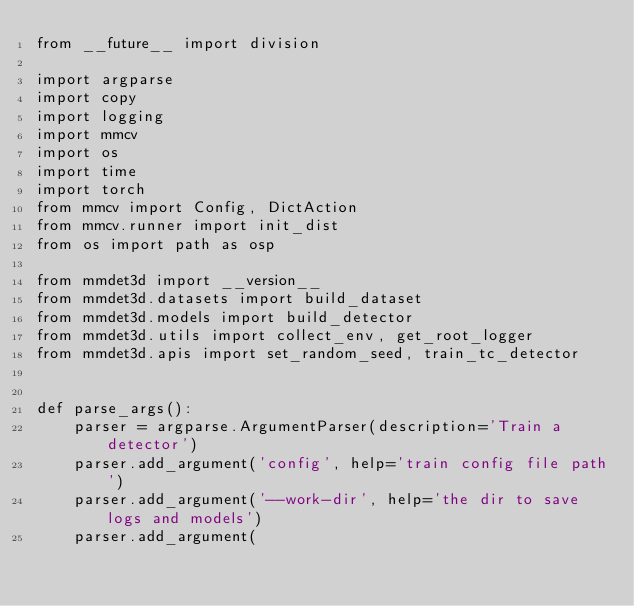<code> <loc_0><loc_0><loc_500><loc_500><_Python_>from __future__ import division

import argparse
import copy
import logging
import mmcv
import os
import time
import torch
from mmcv import Config, DictAction
from mmcv.runner import init_dist
from os import path as osp

from mmdet3d import __version__
from mmdet3d.datasets import build_dataset
from mmdet3d.models import build_detector
from mmdet3d.utils import collect_env, get_root_logger
from mmdet3d.apis import set_random_seed, train_tc_detector


def parse_args():
    parser = argparse.ArgumentParser(description='Train a detector')
    parser.add_argument('config', help='train config file path')
    parser.add_argument('--work-dir', help='the dir to save logs and models')
    parser.add_argument(</code> 